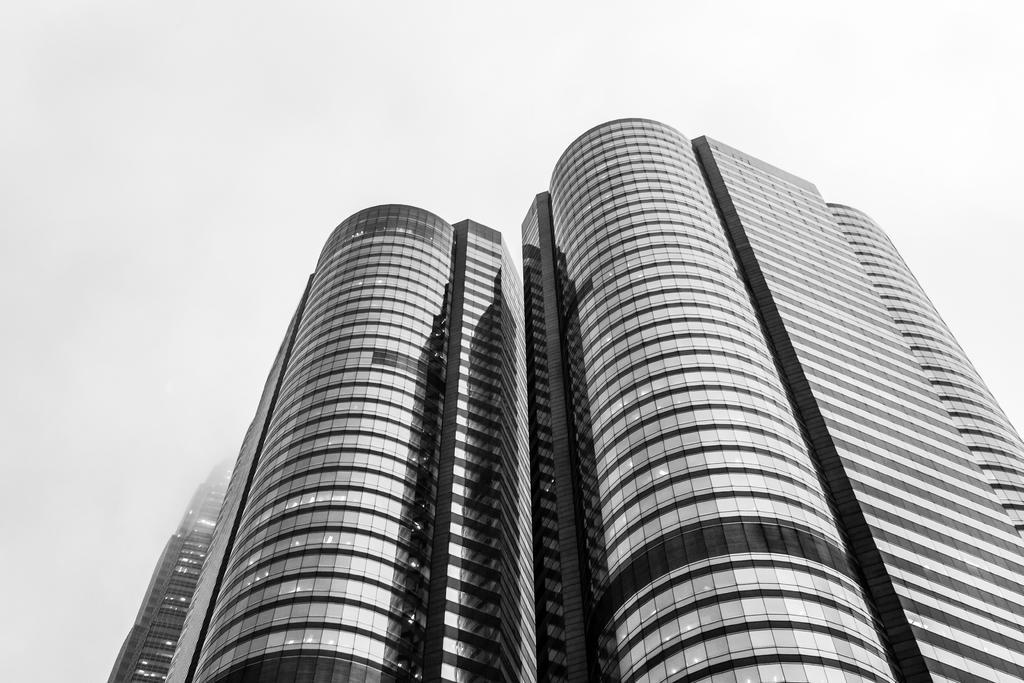Can you describe this image briefly? In the picture I can see a building which has glasses on it. 